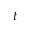Convert formula to latex. <formula><loc_0><loc_0><loc_500><loc_500>t</formula> 